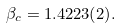<formula> <loc_0><loc_0><loc_500><loc_500>\beta _ { c } = 1 . 4 2 2 3 ( 2 ) .</formula> 